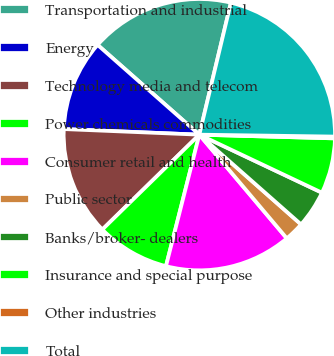Convert chart. <chart><loc_0><loc_0><loc_500><loc_500><pie_chart><fcel>Transportation and industrial<fcel>Energy<fcel>Technology media and telecom<fcel>Power chemicals commodities<fcel>Consumer retail and health<fcel>Public sector<fcel>Banks/broker- dealers<fcel>Insurance and special purpose<fcel>Other industries<fcel>Total<nl><fcel>17.23%<fcel>10.85%<fcel>12.98%<fcel>8.72%<fcel>15.11%<fcel>2.34%<fcel>4.47%<fcel>6.6%<fcel>0.21%<fcel>21.49%<nl></chart> 